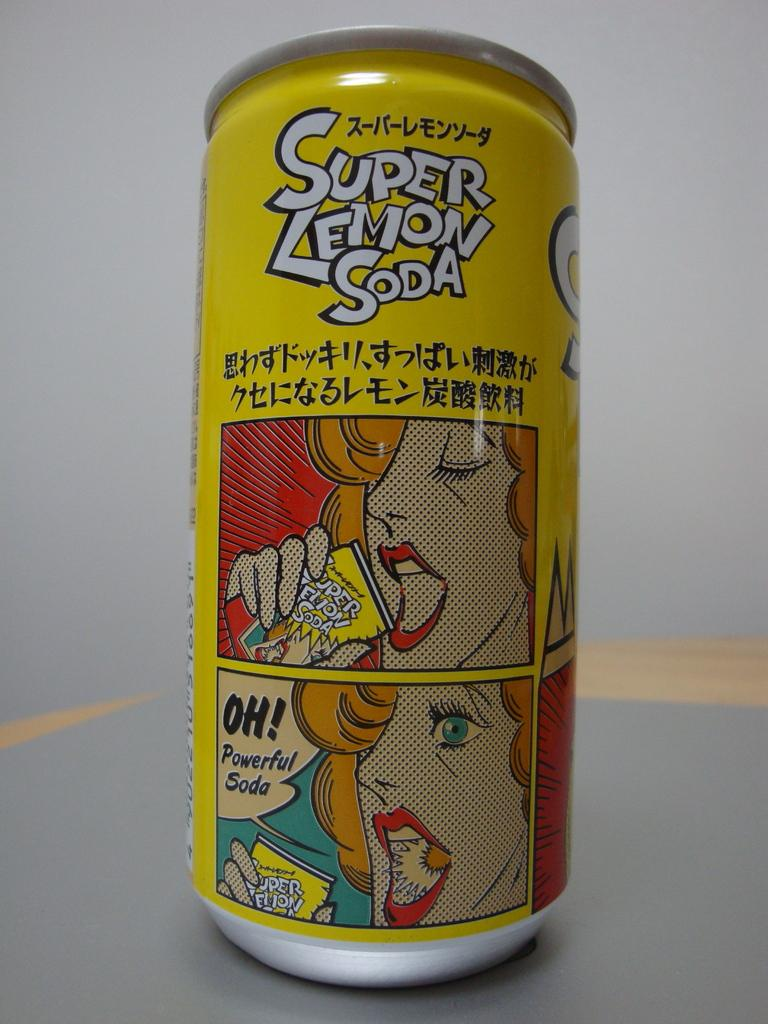<image>
Write a terse but informative summary of the picture. Super Lemon Soda has cartoon panels of a woman on it. 